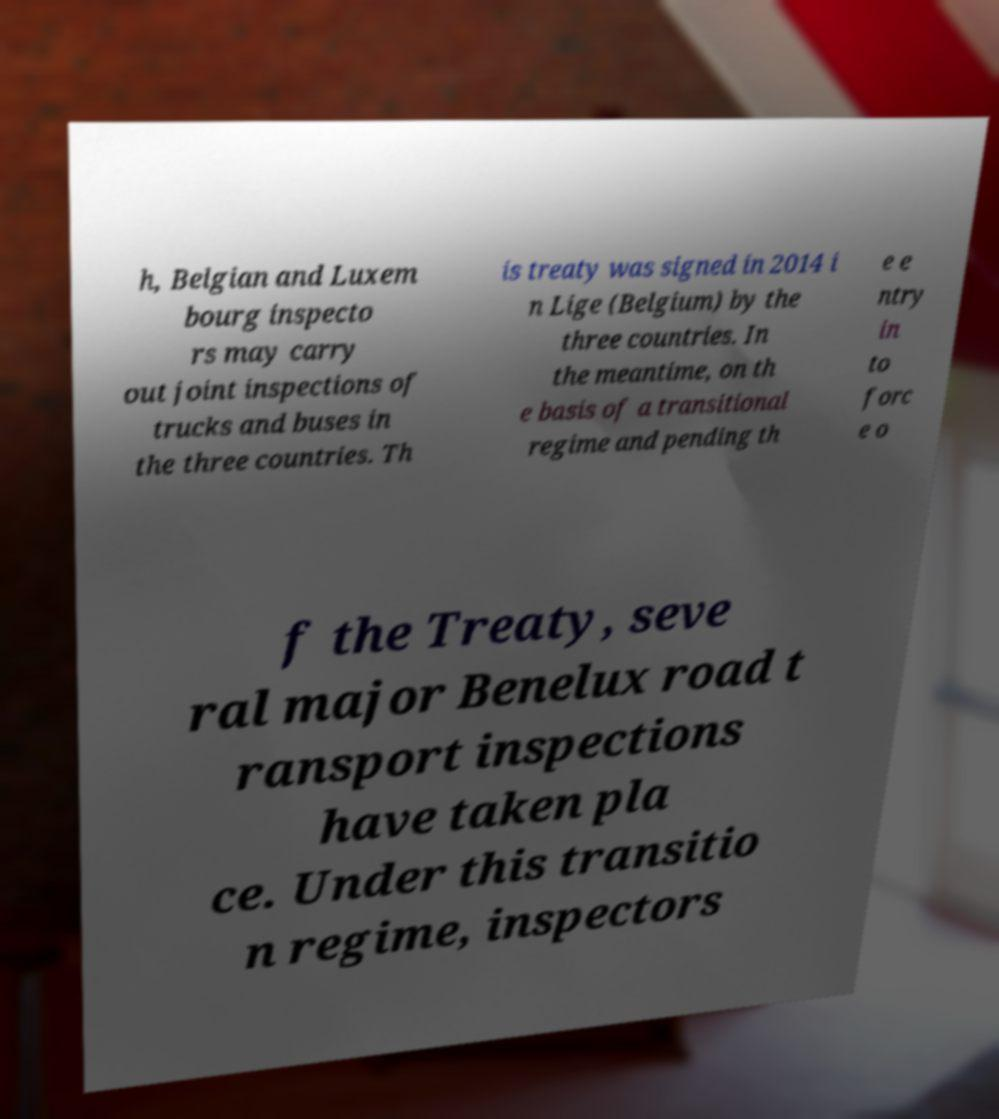Can you accurately transcribe the text from the provided image for me? h, Belgian and Luxem bourg inspecto rs may carry out joint inspections of trucks and buses in the three countries. Th is treaty was signed in 2014 i n Lige (Belgium) by the three countries. In the meantime, on th e basis of a transitional regime and pending th e e ntry in to forc e o f the Treaty, seve ral major Benelux road t ransport inspections have taken pla ce. Under this transitio n regime, inspectors 